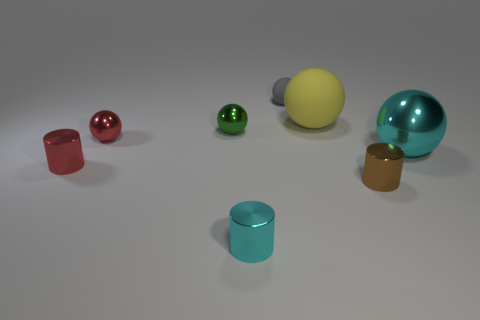What is the texture and material appearance of the objects? The objects have a smooth and shiny texture, suggesting they are made of materials like plastic or polished metal, which give them a reflective surface. The lighting in the image highlights their glossy finish. How does the lighting in the image affect the appearance of these objects? The lighting in the image casts soft shadows and creates highlights on the objects, enhancing their three-dimensional form. It brings out the specular reflections on their surfaces, emphasizing their glossy texture and providing a sense of depth to the scene. 